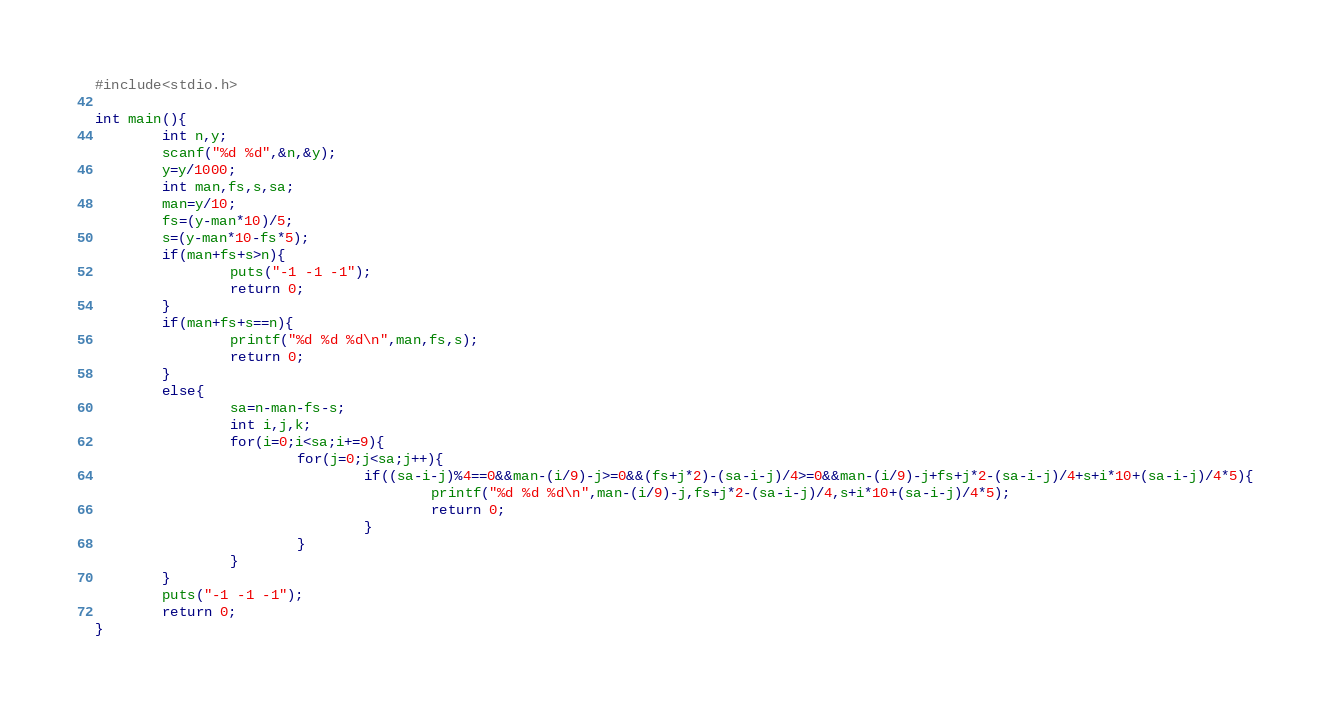Convert code to text. <code><loc_0><loc_0><loc_500><loc_500><_C_>#include<stdio.h>

int main(){
		int n,y;
		scanf("%d %d",&n,&y);
		y=y/1000;
		int man,fs,s,sa;
		man=y/10;
		fs=(y-man*10)/5;
		s=(y-man*10-fs*5);
		if(man+fs+s>n){
				puts("-1 -1 -1");
				return 0;
		}
		if(man+fs+s==n){
				printf("%d %d %d\n",man,fs,s);
				return 0;
		}
		else{
				sa=n-man-fs-s;
				int i,j,k;
				for(i=0;i<sa;i+=9){
						for(j=0;j<sa;j++){
								if((sa-i-j)%4==0&&man-(i/9)-j>=0&&(fs+j*2)-(sa-i-j)/4>=0&&man-(i/9)-j+fs+j*2-(sa-i-j)/4+s+i*10+(sa-i-j)/4*5){
										printf("%d %d %d\n",man-(i/9)-j,fs+j*2-(sa-i-j)/4,s+i*10+(sa-i-j)/4*5);
										return 0;
								}
						}
				}		
		}
		puts("-1 -1 -1");
		return 0;
}				
</code> 